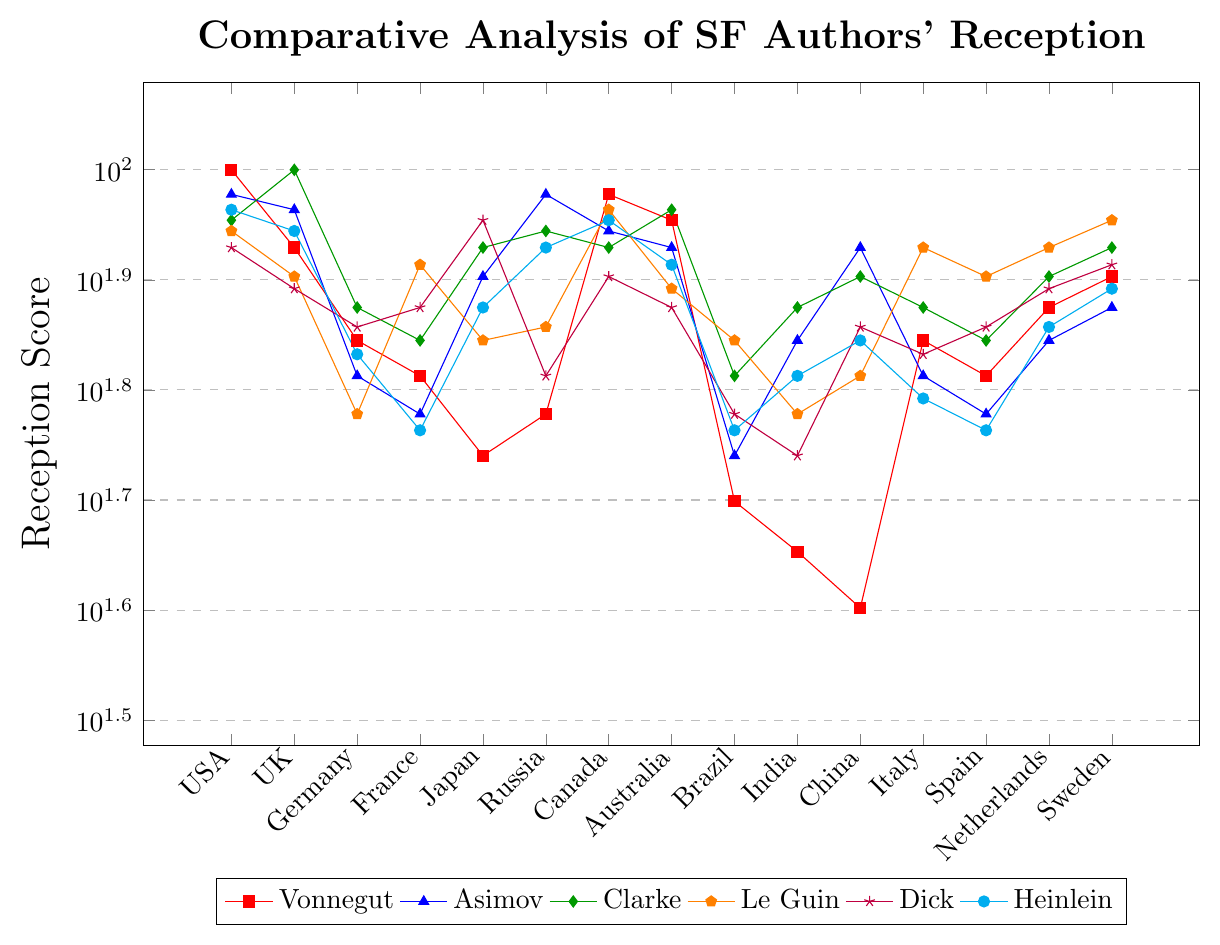Which author has the highest reception score in the USA? Observing the red, blue, green, orange, purple, and cyan markers, Vonnegut (red) has the highest reception score of 100 in the USA.
Answer: Vonnegut Which country shows the greatest difference in reception scores between Asimov and Vonnegut? Looking at the individual countries, the score differences (absolute value) can be calculated: USA (5), UK (7), Germany (5), France (5), Japan (25), Russia (35), Canada (7), Australia (5), Brazil (5), India (25), China (45), Italy (5), Spain (5), Netherlands (5), Sweden (5). China shows the greatest score difference of 45.
Answer: China Among Vonnegut, Asimov, and Clarke, which author has the lowest reception score in Japan? Vonnegut’s score is 55, Asimov’s is 80, and Clarke’s is 85. Comparing these values, Vonnegut has the lowest score.
Answer: Vonnegut What is the median reception score for Heinlein across all countries? Sorting Heinlein’s scores: [58, 58, 60, 62, 65, 68, 70, 72, 75, 75, 78, 82, 85, 88, 90], the middle value (8th value) in this array is 72.
Answer: 72 Which country gives Le Guin the highest reception score, and what is that score? Observing the orange markers, the highest score for Le Guin is in Sweden with a value of 90.
Answer: Sweden, 90 Is Vonnegut's reception score higher or lower than Heinlein's in Canada? Vonnegut’s score in Canada is 95, and Heinlein’s is 90. Thus, Vonnegut’s score is higher.
Answer: Higher What is the average reception score of Clarke in the USA, UK, and Australia combined? The reception scores are USA (90), UK (100), Australia (92). Summing these scores and dividing by 3: (90 + 100 + 92) / 3 = 282 / 3 = 94
Answer: 94 How does the reception score of Dick in Russia compare with Heinlein's in the same country? Dick’s score is 65 in Russia, whereas Heinlein’s is 85. Heinlein's score is higher.
Answer: Heinlein's score is higher Which country has the most varied reception scores (highest range) for the authors shown, and what is the range? Calculating ranges for each country, the country with the highest range is China (85 - 40) = 45.
Answer: China, 45 What is the common lowest reception score across all countries and all authors? The lowest value from the dataset occurs with Vonnegut in China with a score of 40, and similarly across other authors, no scores fall below this value.
Answer: 40 